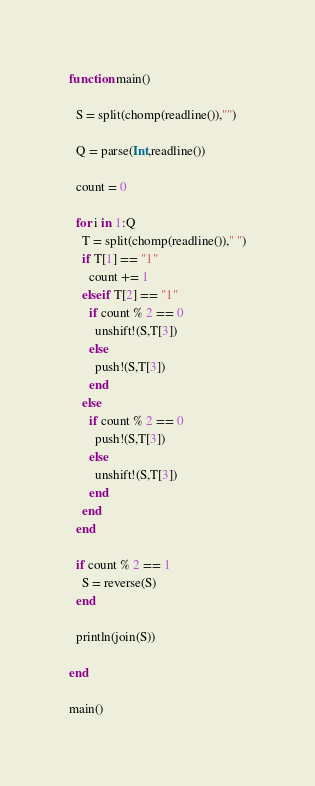<code> <loc_0><loc_0><loc_500><loc_500><_Julia_>function main()
  
  S = split(chomp(readline()),"")
  
  Q = parse(Int,readline())
  
  count = 0
  
  for i in 1:Q
    T = split(chomp(readline())," ")
    if T[1] == "1"
      count += 1
    elseif T[2] == "1"
      if count % 2 == 0
        unshift!(S,T[3])
      else
        push!(S,T[3])
      end
    else
      if count % 2 == 0
        push!(S,T[3])
      else
        unshift!(S,T[3])
      end
    end
  end
  
  if count % 2 == 1
    S = reverse(S)
  end
  
  println(join(S))
  
end

main()</code> 